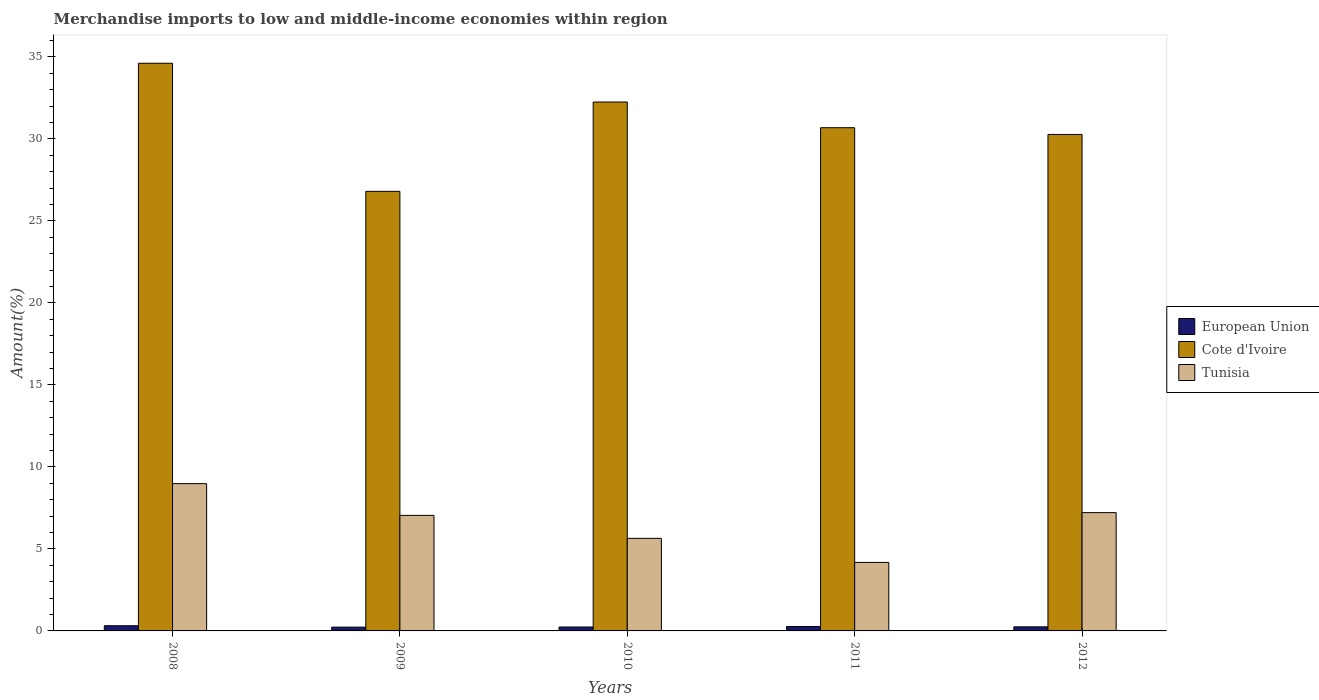How many different coloured bars are there?
Ensure brevity in your answer.  3. How many groups of bars are there?
Offer a very short reply. 5. How many bars are there on the 5th tick from the right?
Offer a very short reply. 3. In how many cases, is the number of bars for a given year not equal to the number of legend labels?
Provide a short and direct response. 0. What is the percentage of amount earned from merchandise imports in European Union in 2008?
Offer a very short reply. 0.32. Across all years, what is the maximum percentage of amount earned from merchandise imports in European Union?
Your response must be concise. 0.32. Across all years, what is the minimum percentage of amount earned from merchandise imports in Tunisia?
Provide a short and direct response. 4.18. In which year was the percentage of amount earned from merchandise imports in Cote d'Ivoire maximum?
Your response must be concise. 2008. What is the total percentage of amount earned from merchandise imports in European Union in the graph?
Offer a terse response. 1.3. What is the difference between the percentage of amount earned from merchandise imports in Cote d'Ivoire in 2008 and that in 2010?
Offer a very short reply. 2.36. What is the difference between the percentage of amount earned from merchandise imports in Tunisia in 2008 and the percentage of amount earned from merchandise imports in European Union in 2012?
Keep it short and to the point. 8.73. What is the average percentage of amount earned from merchandise imports in European Union per year?
Your response must be concise. 0.26. In the year 2008, what is the difference between the percentage of amount earned from merchandise imports in Tunisia and percentage of amount earned from merchandise imports in Cote d'Ivoire?
Your answer should be very brief. -25.63. In how many years, is the percentage of amount earned from merchandise imports in Cote d'Ivoire greater than 8 %?
Keep it short and to the point. 5. What is the ratio of the percentage of amount earned from merchandise imports in Cote d'Ivoire in 2010 to that in 2011?
Your answer should be very brief. 1.05. Is the difference between the percentage of amount earned from merchandise imports in Tunisia in 2010 and 2011 greater than the difference between the percentage of amount earned from merchandise imports in Cote d'Ivoire in 2010 and 2011?
Offer a very short reply. No. What is the difference between the highest and the second highest percentage of amount earned from merchandise imports in European Union?
Offer a very short reply. 0.05. What is the difference between the highest and the lowest percentage of amount earned from merchandise imports in Cote d'Ivoire?
Make the answer very short. 7.81. Is the sum of the percentage of amount earned from merchandise imports in European Union in 2008 and 2011 greater than the maximum percentage of amount earned from merchandise imports in Tunisia across all years?
Make the answer very short. No. What does the 2nd bar from the left in 2009 represents?
Provide a short and direct response. Cote d'Ivoire. What does the 1st bar from the right in 2008 represents?
Make the answer very short. Tunisia. Is it the case that in every year, the sum of the percentage of amount earned from merchandise imports in Tunisia and percentage of amount earned from merchandise imports in Cote d'Ivoire is greater than the percentage of amount earned from merchandise imports in European Union?
Provide a short and direct response. Yes. How many bars are there?
Provide a succinct answer. 15. Are all the bars in the graph horizontal?
Your response must be concise. No. Does the graph contain any zero values?
Offer a very short reply. No. How many legend labels are there?
Make the answer very short. 3. What is the title of the graph?
Make the answer very short. Merchandise imports to low and middle-income economies within region. Does "Haiti" appear as one of the legend labels in the graph?
Provide a short and direct response. No. What is the label or title of the X-axis?
Offer a terse response. Years. What is the label or title of the Y-axis?
Make the answer very short. Amount(%). What is the Amount(%) in European Union in 2008?
Give a very brief answer. 0.32. What is the Amount(%) in Cote d'Ivoire in 2008?
Your response must be concise. 34.61. What is the Amount(%) in Tunisia in 2008?
Keep it short and to the point. 8.98. What is the Amount(%) in European Union in 2009?
Provide a succinct answer. 0.23. What is the Amount(%) of Cote d'Ivoire in 2009?
Offer a very short reply. 26.8. What is the Amount(%) of Tunisia in 2009?
Give a very brief answer. 7.04. What is the Amount(%) in European Union in 2010?
Your answer should be compact. 0.24. What is the Amount(%) of Cote d'Ivoire in 2010?
Keep it short and to the point. 32.25. What is the Amount(%) of Tunisia in 2010?
Keep it short and to the point. 5.64. What is the Amount(%) in European Union in 2011?
Your response must be concise. 0.27. What is the Amount(%) in Cote d'Ivoire in 2011?
Provide a short and direct response. 30.68. What is the Amount(%) of Tunisia in 2011?
Offer a terse response. 4.18. What is the Amount(%) in European Union in 2012?
Give a very brief answer. 0.25. What is the Amount(%) in Cote d'Ivoire in 2012?
Provide a succinct answer. 30.27. What is the Amount(%) of Tunisia in 2012?
Make the answer very short. 7.21. Across all years, what is the maximum Amount(%) of European Union?
Offer a terse response. 0.32. Across all years, what is the maximum Amount(%) in Cote d'Ivoire?
Give a very brief answer. 34.61. Across all years, what is the maximum Amount(%) in Tunisia?
Ensure brevity in your answer.  8.98. Across all years, what is the minimum Amount(%) of European Union?
Your answer should be very brief. 0.23. Across all years, what is the minimum Amount(%) in Cote d'Ivoire?
Provide a succinct answer. 26.8. Across all years, what is the minimum Amount(%) in Tunisia?
Give a very brief answer. 4.18. What is the total Amount(%) of European Union in the graph?
Provide a succinct answer. 1.3. What is the total Amount(%) of Cote d'Ivoire in the graph?
Provide a short and direct response. 154.61. What is the total Amount(%) in Tunisia in the graph?
Keep it short and to the point. 33.06. What is the difference between the Amount(%) in European Union in 2008 and that in 2009?
Ensure brevity in your answer.  0.09. What is the difference between the Amount(%) in Cote d'Ivoire in 2008 and that in 2009?
Ensure brevity in your answer.  7.81. What is the difference between the Amount(%) in Tunisia in 2008 and that in 2009?
Your response must be concise. 1.94. What is the difference between the Amount(%) of European Union in 2008 and that in 2010?
Offer a very short reply. 0.08. What is the difference between the Amount(%) in Cote d'Ivoire in 2008 and that in 2010?
Your answer should be very brief. 2.36. What is the difference between the Amount(%) of Tunisia in 2008 and that in 2010?
Keep it short and to the point. 3.34. What is the difference between the Amount(%) of European Union in 2008 and that in 2011?
Offer a terse response. 0.05. What is the difference between the Amount(%) of Cote d'Ivoire in 2008 and that in 2011?
Ensure brevity in your answer.  3.93. What is the difference between the Amount(%) in Tunisia in 2008 and that in 2011?
Your answer should be very brief. 4.8. What is the difference between the Amount(%) of European Union in 2008 and that in 2012?
Your answer should be very brief. 0.07. What is the difference between the Amount(%) in Cote d'Ivoire in 2008 and that in 2012?
Make the answer very short. 4.34. What is the difference between the Amount(%) in Tunisia in 2008 and that in 2012?
Your response must be concise. 1.77. What is the difference between the Amount(%) of European Union in 2009 and that in 2010?
Provide a succinct answer. -0.01. What is the difference between the Amount(%) in Cote d'Ivoire in 2009 and that in 2010?
Offer a very short reply. -5.45. What is the difference between the Amount(%) in Tunisia in 2009 and that in 2010?
Your answer should be compact. 1.4. What is the difference between the Amount(%) of European Union in 2009 and that in 2011?
Your answer should be compact. -0.04. What is the difference between the Amount(%) in Cote d'Ivoire in 2009 and that in 2011?
Provide a succinct answer. -3.88. What is the difference between the Amount(%) of Tunisia in 2009 and that in 2011?
Ensure brevity in your answer.  2.87. What is the difference between the Amount(%) in European Union in 2009 and that in 2012?
Provide a succinct answer. -0.02. What is the difference between the Amount(%) in Cote d'Ivoire in 2009 and that in 2012?
Offer a terse response. -3.47. What is the difference between the Amount(%) in Tunisia in 2009 and that in 2012?
Your answer should be compact. -0.17. What is the difference between the Amount(%) of European Union in 2010 and that in 2011?
Make the answer very short. -0.03. What is the difference between the Amount(%) in Cote d'Ivoire in 2010 and that in 2011?
Make the answer very short. 1.57. What is the difference between the Amount(%) of Tunisia in 2010 and that in 2011?
Ensure brevity in your answer.  1.47. What is the difference between the Amount(%) in European Union in 2010 and that in 2012?
Keep it short and to the point. -0.01. What is the difference between the Amount(%) in Cote d'Ivoire in 2010 and that in 2012?
Make the answer very short. 1.98. What is the difference between the Amount(%) of Tunisia in 2010 and that in 2012?
Your answer should be compact. -1.57. What is the difference between the Amount(%) in European Union in 2011 and that in 2012?
Offer a terse response. 0.02. What is the difference between the Amount(%) of Cote d'Ivoire in 2011 and that in 2012?
Your response must be concise. 0.41. What is the difference between the Amount(%) in Tunisia in 2011 and that in 2012?
Your answer should be compact. -3.04. What is the difference between the Amount(%) of European Union in 2008 and the Amount(%) of Cote d'Ivoire in 2009?
Your answer should be very brief. -26.48. What is the difference between the Amount(%) in European Union in 2008 and the Amount(%) in Tunisia in 2009?
Your response must be concise. -6.73. What is the difference between the Amount(%) in Cote d'Ivoire in 2008 and the Amount(%) in Tunisia in 2009?
Ensure brevity in your answer.  27.57. What is the difference between the Amount(%) in European Union in 2008 and the Amount(%) in Cote d'Ivoire in 2010?
Ensure brevity in your answer.  -31.93. What is the difference between the Amount(%) of European Union in 2008 and the Amount(%) of Tunisia in 2010?
Offer a terse response. -5.33. What is the difference between the Amount(%) of Cote d'Ivoire in 2008 and the Amount(%) of Tunisia in 2010?
Your answer should be very brief. 28.97. What is the difference between the Amount(%) of European Union in 2008 and the Amount(%) of Cote d'Ivoire in 2011?
Provide a short and direct response. -30.36. What is the difference between the Amount(%) in European Union in 2008 and the Amount(%) in Tunisia in 2011?
Your answer should be very brief. -3.86. What is the difference between the Amount(%) in Cote d'Ivoire in 2008 and the Amount(%) in Tunisia in 2011?
Your answer should be compact. 30.43. What is the difference between the Amount(%) in European Union in 2008 and the Amount(%) in Cote d'Ivoire in 2012?
Your answer should be very brief. -29.95. What is the difference between the Amount(%) in European Union in 2008 and the Amount(%) in Tunisia in 2012?
Your answer should be compact. -6.9. What is the difference between the Amount(%) in Cote d'Ivoire in 2008 and the Amount(%) in Tunisia in 2012?
Keep it short and to the point. 27.4. What is the difference between the Amount(%) of European Union in 2009 and the Amount(%) of Cote d'Ivoire in 2010?
Make the answer very short. -32.02. What is the difference between the Amount(%) of European Union in 2009 and the Amount(%) of Tunisia in 2010?
Provide a short and direct response. -5.41. What is the difference between the Amount(%) of Cote d'Ivoire in 2009 and the Amount(%) of Tunisia in 2010?
Make the answer very short. 21.16. What is the difference between the Amount(%) in European Union in 2009 and the Amount(%) in Cote d'Ivoire in 2011?
Your answer should be very brief. -30.45. What is the difference between the Amount(%) in European Union in 2009 and the Amount(%) in Tunisia in 2011?
Offer a very short reply. -3.95. What is the difference between the Amount(%) in Cote d'Ivoire in 2009 and the Amount(%) in Tunisia in 2011?
Provide a short and direct response. 22.62. What is the difference between the Amount(%) of European Union in 2009 and the Amount(%) of Cote d'Ivoire in 2012?
Keep it short and to the point. -30.04. What is the difference between the Amount(%) in European Union in 2009 and the Amount(%) in Tunisia in 2012?
Your response must be concise. -6.98. What is the difference between the Amount(%) of Cote d'Ivoire in 2009 and the Amount(%) of Tunisia in 2012?
Make the answer very short. 19.59. What is the difference between the Amount(%) in European Union in 2010 and the Amount(%) in Cote d'Ivoire in 2011?
Your response must be concise. -30.44. What is the difference between the Amount(%) in European Union in 2010 and the Amount(%) in Tunisia in 2011?
Keep it short and to the point. -3.94. What is the difference between the Amount(%) of Cote d'Ivoire in 2010 and the Amount(%) of Tunisia in 2011?
Ensure brevity in your answer.  28.07. What is the difference between the Amount(%) in European Union in 2010 and the Amount(%) in Cote d'Ivoire in 2012?
Your answer should be very brief. -30.03. What is the difference between the Amount(%) in European Union in 2010 and the Amount(%) in Tunisia in 2012?
Offer a very short reply. -6.97. What is the difference between the Amount(%) of Cote d'Ivoire in 2010 and the Amount(%) of Tunisia in 2012?
Offer a very short reply. 25.03. What is the difference between the Amount(%) of European Union in 2011 and the Amount(%) of Cote d'Ivoire in 2012?
Give a very brief answer. -30. What is the difference between the Amount(%) in European Union in 2011 and the Amount(%) in Tunisia in 2012?
Make the answer very short. -6.94. What is the difference between the Amount(%) in Cote d'Ivoire in 2011 and the Amount(%) in Tunisia in 2012?
Your response must be concise. 23.47. What is the average Amount(%) in European Union per year?
Your answer should be very brief. 0.26. What is the average Amount(%) in Cote d'Ivoire per year?
Your answer should be very brief. 30.92. What is the average Amount(%) in Tunisia per year?
Offer a very short reply. 6.61. In the year 2008, what is the difference between the Amount(%) in European Union and Amount(%) in Cote d'Ivoire?
Provide a succinct answer. -34.29. In the year 2008, what is the difference between the Amount(%) in European Union and Amount(%) in Tunisia?
Offer a very short reply. -8.66. In the year 2008, what is the difference between the Amount(%) of Cote d'Ivoire and Amount(%) of Tunisia?
Make the answer very short. 25.63. In the year 2009, what is the difference between the Amount(%) in European Union and Amount(%) in Cote d'Ivoire?
Ensure brevity in your answer.  -26.57. In the year 2009, what is the difference between the Amount(%) in European Union and Amount(%) in Tunisia?
Offer a terse response. -6.81. In the year 2009, what is the difference between the Amount(%) in Cote d'Ivoire and Amount(%) in Tunisia?
Keep it short and to the point. 19.76. In the year 2010, what is the difference between the Amount(%) in European Union and Amount(%) in Cote d'Ivoire?
Your answer should be compact. -32.01. In the year 2010, what is the difference between the Amount(%) of European Union and Amount(%) of Tunisia?
Your answer should be very brief. -5.4. In the year 2010, what is the difference between the Amount(%) in Cote d'Ivoire and Amount(%) in Tunisia?
Provide a short and direct response. 26.6. In the year 2011, what is the difference between the Amount(%) of European Union and Amount(%) of Cote d'Ivoire?
Your response must be concise. -30.41. In the year 2011, what is the difference between the Amount(%) of European Union and Amount(%) of Tunisia?
Your answer should be very brief. -3.91. In the year 2011, what is the difference between the Amount(%) in Cote d'Ivoire and Amount(%) in Tunisia?
Provide a short and direct response. 26.5. In the year 2012, what is the difference between the Amount(%) of European Union and Amount(%) of Cote d'Ivoire?
Your response must be concise. -30.02. In the year 2012, what is the difference between the Amount(%) in European Union and Amount(%) in Tunisia?
Provide a short and direct response. -6.96. In the year 2012, what is the difference between the Amount(%) in Cote d'Ivoire and Amount(%) in Tunisia?
Keep it short and to the point. 23.06. What is the ratio of the Amount(%) of European Union in 2008 to that in 2009?
Make the answer very short. 1.37. What is the ratio of the Amount(%) in Cote d'Ivoire in 2008 to that in 2009?
Make the answer very short. 1.29. What is the ratio of the Amount(%) in Tunisia in 2008 to that in 2009?
Keep it short and to the point. 1.27. What is the ratio of the Amount(%) in European Union in 2008 to that in 2010?
Your answer should be very brief. 1.33. What is the ratio of the Amount(%) of Cote d'Ivoire in 2008 to that in 2010?
Keep it short and to the point. 1.07. What is the ratio of the Amount(%) in Tunisia in 2008 to that in 2010?
Provide a short and direct response. 1.59. What is the ratio of the Amount(%) of European Union in 2008 to that in 2011?
Your answer should be compact. 1.19. What is the ratio of the Amount(%) in Cote d'Ivoire in 2008 to that in 2011?
Provide a succinct answer. 1.13. What is the ratio of the Amount(%) of Tunisia in 2008 to that in 2011?
Provide a succinct answer. 2.15. What is the ratio of the Amount(%) in European Union in 2008 to that in 2012?
Offer a terse response. 1.28. What is the ratio of the Amount(%) of Cote d'Ivoire in 2008 to that in 2012?
Your answer should be compact. 1.14. What is the ratio of the Amount(%) in Tunisia in 2008 to that in 2012?
Your response must be concise. 1.25. What is the ratio of the Amount(%) of European Union in 2009 to that in 2010?
Offer a very short reply. 0.96. What is the ratio of the Amount(%) of Cote d'Ivoire in 2009 to that in 2010?
Your answer should be compact. 0.83. What is the ratio of the Amount(%) of Tunisia in 2009 to that in 2010?
Ensure brevity in your answer.  1.25. What is the ratio of the Amount(%) of European Union in 2009 to that in 2011?
Provide a succinct answer. 0.86. What is the ratio of the Amount(%) of Cote d'Ivoire in 2009 to that in 2011?
Provide a short and direct response. 0.87. What is the ratio of the Amount(%) in Tunisia in 2009 to that in 2011?
Provide a succinct answer. 1.69. What is the ratio of the Amount(%) in European Union in 2009 to that in 2012?
Make the answer very short. 0.93. What is the ratio of the Amount(%) in Cote d'Ivoire in 2009 to that in 2012?
Offer a very short reply. 0.89. What is the ratio of the Amount(%) of Tunisia in 2009 to that in 2012?
Make the answer very short. 0.98. What is the ratio of the Amount(%) in European Union in 2010 to that in 2011?
Make the answer very short. 0.89. What is the ratio of the Amount(%) of Cote d'Ivoire in 2010 to that in 2011?
Provide a succinct answer. 1.05. What is the ratio of the Amount(%) of Tunisia in 2010 to that in 2011?
Provide a short and direct response. 1.35. What is the ratio of the Amount(%) of European Union in 2010 to that in 2012?
Offer a very short reply. 0.96. What is the ratio of the Amount(%) in Cote d'Ivoire in 2010 to that in 2012?
Make the answer very short. 1.07. What is the ratio of the Amount(%) in Tunisia in 2010 to that in 2012?
Provide a succinct answer. 0.78. What is the ratio of the Amount(%) in European Union in 2011 to that in 2012?
Provide a short and direct response. 1.08. What is the ratio of the Amount(%) of Cote d'Ivoire in 2011 to that in 2012?
Offer a terse response. 1.01. What is the ratio of the Amount(%) of Tunisia in 2011 to that in 2012?
Make the answer very short. 0.58. What is the difference between the highest and the second highest Amount(%) in European Union?
Your response must be concise. 0.05. What is the difference between the highest and the second highest Amount(%) in Cote d'Ivoire?
Your answer should be compact. 2.36. What is the difference between the highest and the second highest Amount(%) in Tunisia?
Give a very brief answer. 1.77. What is the difference between the highest and the lowest Amount(%) in European Union?
Provide a short and direct response. 0.09. What is the difference between the highest and the lowest Amount(%) of Cote d'Ivoire?
Make the answer very short. 7.81. What is the difference between the highest and the lowest Amount(%) in Tunisia?
Give a very brief answer. 4.8. 